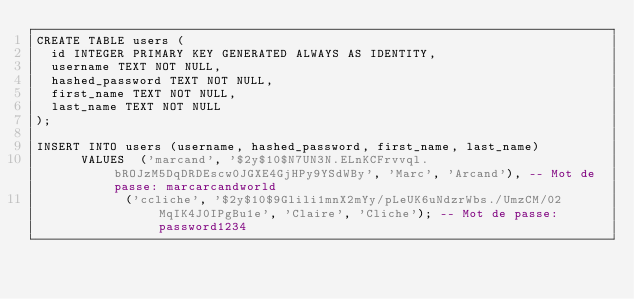Convert code to text. <code><loc_0><loc_0><loc_500><loc_500><_SQL_>CREATE TABLE users (
	id INTEGER PRIMARY KEY GENERATED ALWAYS AS IDENTITY,
	username TEXT NOT NULL,
	hashed_password TEXT NOT NULL,
	first_name TEXT NOT NULL,
	last_name TEXT NOT NULL
);

INSERT INTO users (username, hashed_password, first_name, last_name)
		  VALUES  ('marcand', '$2y$10$N7UN3N.ELnKCFrvvql.bROJzM5DqDRDEscw0JGXE4GjHPy9YSdWBy', 'Marc', 'Arcand'), -- Mot de passe: marcarcandworld
		  		  ('ccliche', '$2y$10$9Glili1mnX2mYy/pLeUK6uNdzrWbs./UmzCM/02MqIK4J0IPgBu1e', 'Claire', 'Cliche'); -- Mot de passe: password1234
</code> 